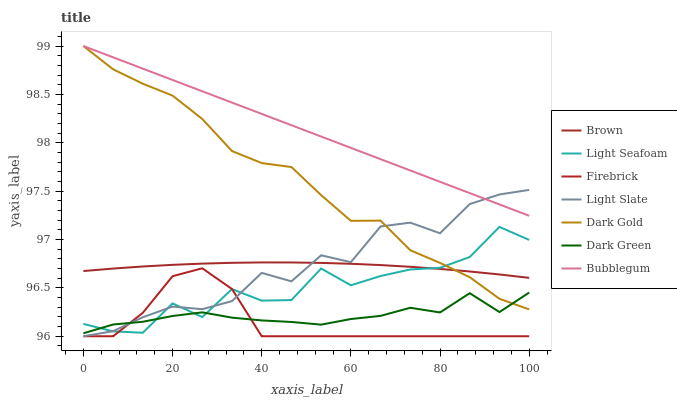Does Firebrick have the minimum area under the curve?
Answer yes or no. Yes. Does Bubblegum have the maximum area under the curve?
Answer yes or no. Yes. Does Dark Gold have the minimum area under the curve?
Answer yes or no. No. Does Dark Gold have the maximum area under the curve?
Answer yes or no. No. Is Bubblegum the smoothest?
Answer yes or no. Yes. Is Light Seafoam the roughest?
Answer yes or no. Yes. Is Dark Gold the smoothest?
Answer yes or no. No. Is Dark Gold the roughest?
Answer yes or no. No. Does Dark Gold have the lowest value?
Answer yes or no. No. Does Bubblegum have the highest value?
Answer yes or no. Yes. Does Light Slate have the highest value?
Answer yes or no. No. Is Light Seafoam less than Bubblegum?
Answer yes or no. Yes. Is Bubblegum greater than Firebrick?
Answer yes or no. Yes. Does Light Seafoam intersect Brown?
Answer yes or no. Yes. Is Light Seafoam less than Brown?
Answer yes or no. No. Is Light Seafoam greater than Brown?
Answer yes or no. No. Does Light Seafoam intersect Bubblegum?
Answer yes or no. No. 